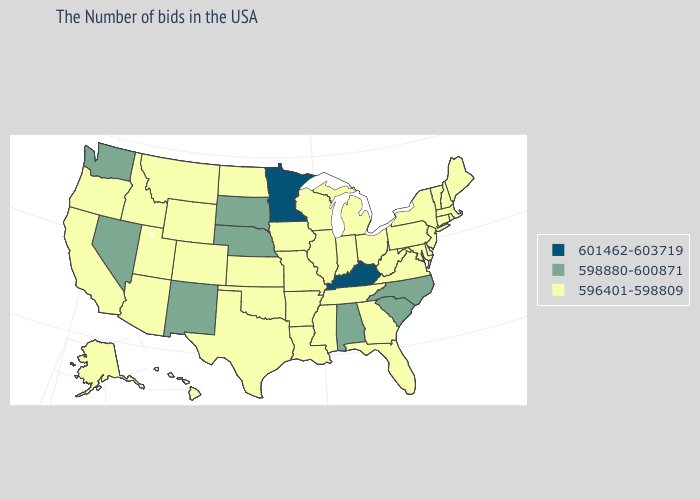What is the value of Utah?
Keep it brief. 596401-598809. Does the first symbol in the legend represent the smallest category?
Write a very short answer. No. Does Mississippi have the lowest value in the USA?
Short answer required. Yes. Does Tennessee have a lower value than Minnesota?
Write a very short answer. Yes. Among the states that border Alabama , which have the highest value?
Be succinct. Florida, Georgia, Tennessee, Mississippi. Name the states that have a value in the range 601462-603719?
Keep it brief. Kentucky, Minnesota. Name the states that have a value in the range 598880-600871?
Quick response, please. North Carolina, South Carolina, Alabama, Nebraska, South Dakota, New Mexico, Nevada, Washington. What is the value of Pennsylvania?
Write a very short answer. 596401-598809. What is the value of Michigan?
Concise answer only. 596401-598809. What is the value of Rhode Island?
Short answer required. 596401-598809. What is the value of Kentucky?
Concise answer only. 601462-603719. Name the states that have a value in the range 598880-600871?
Quick response, please. North Carolina, South Carolina, Alabama, Nebraska, South Dakota, New Mexico, Nevada, Washington. What is the value of Hawaii?
Quick response, please. 596401-598809. How many symbols are there in the legend?
Quick response, please. 3. 